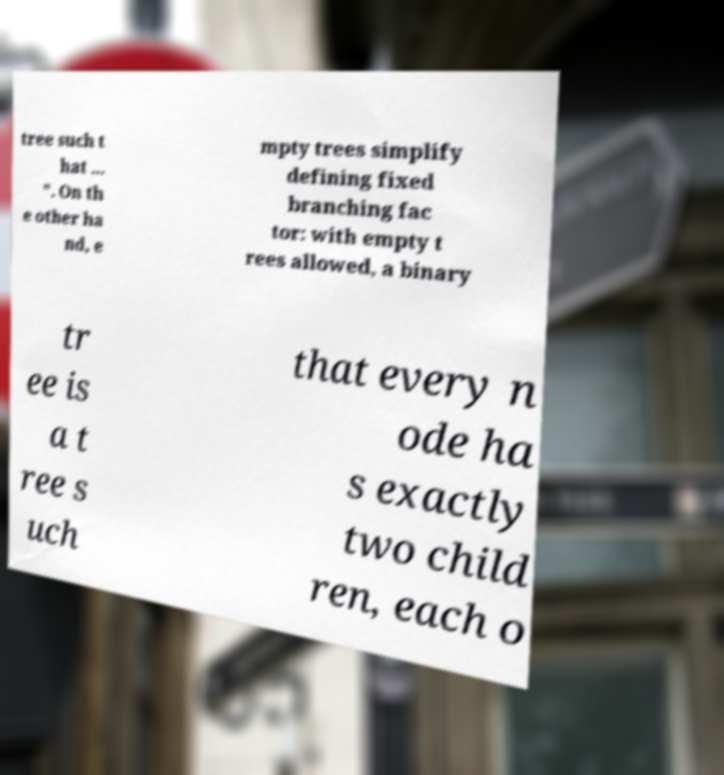Can you accurately transcribe the text from the provided image for me? tree such t hat ... ". On th e other ha nd, e mpty trees simplify defining fixed branching fac tor: with empty t rees allowed, a binary tr ee is a t ree s uch that every n ode ha s exactly two child ren, each o 